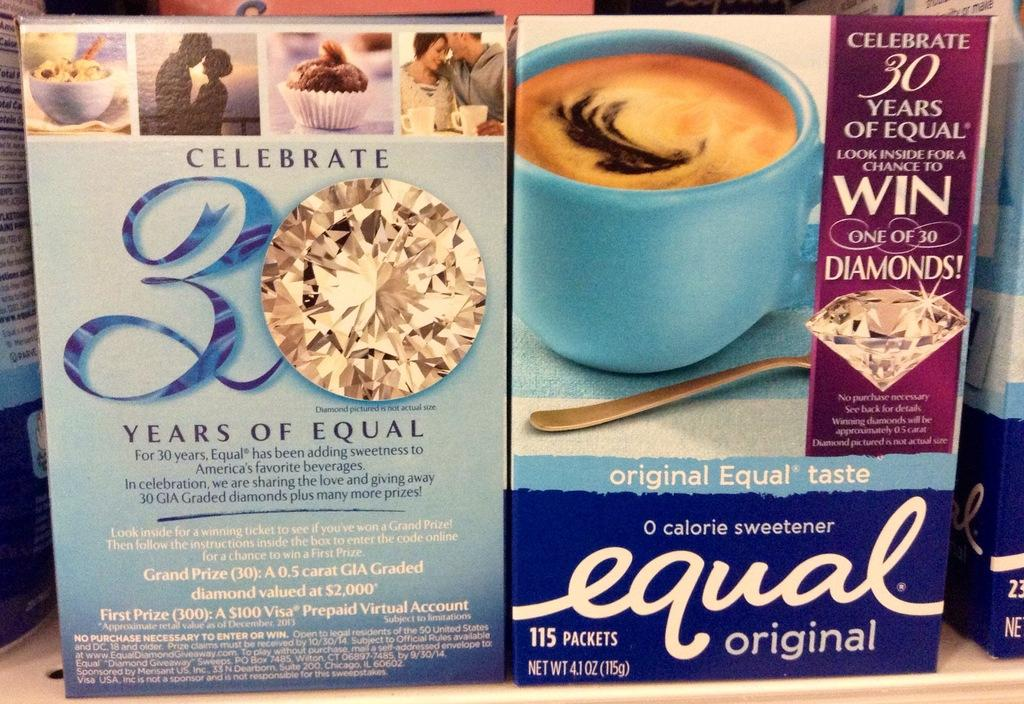<image>
Present a compact description of the photo's key features. Two box showing the front and back of Equal Original. 